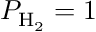<formula> <loc_0><loc_0><loc_500><loc_500>P _ { H _ { 2 } } = 1</formula> 